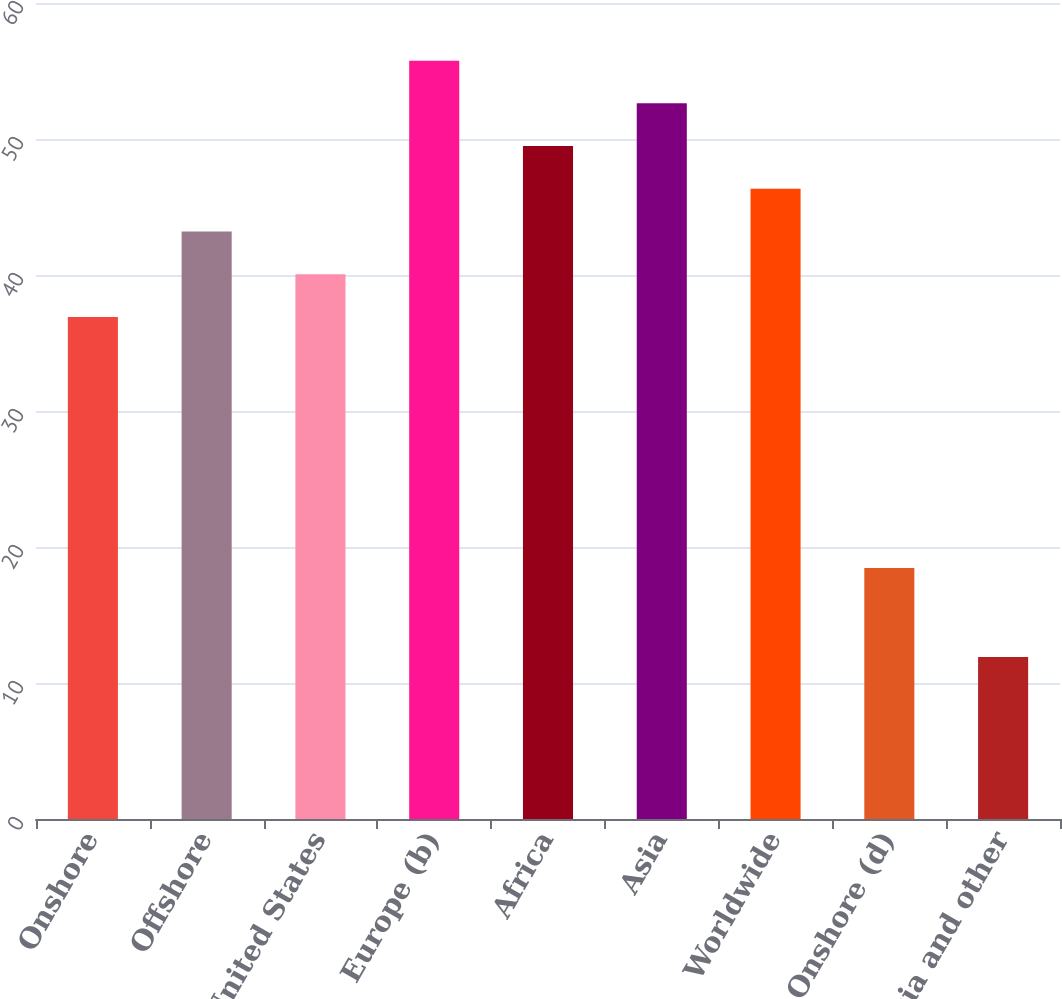<chart> <loc_0><loc_0><loc_500><loc_500><bar_chart><fcel>Onshore<fcel>Offshore<fcel>Total United States<fcel>Europe (b)<fcel>Africa<fcel>Asia<fcel>Worldwide<fcel>Onshore (d)<fcel>Asia and other<nl><fcel>36.92<fcel>43.2<fcel>40.06<fcel>55.76<fcel>49.48<fcel>52.62<fcel>46.34<fcel>18.46<fcel>11.91<nl></chart> 